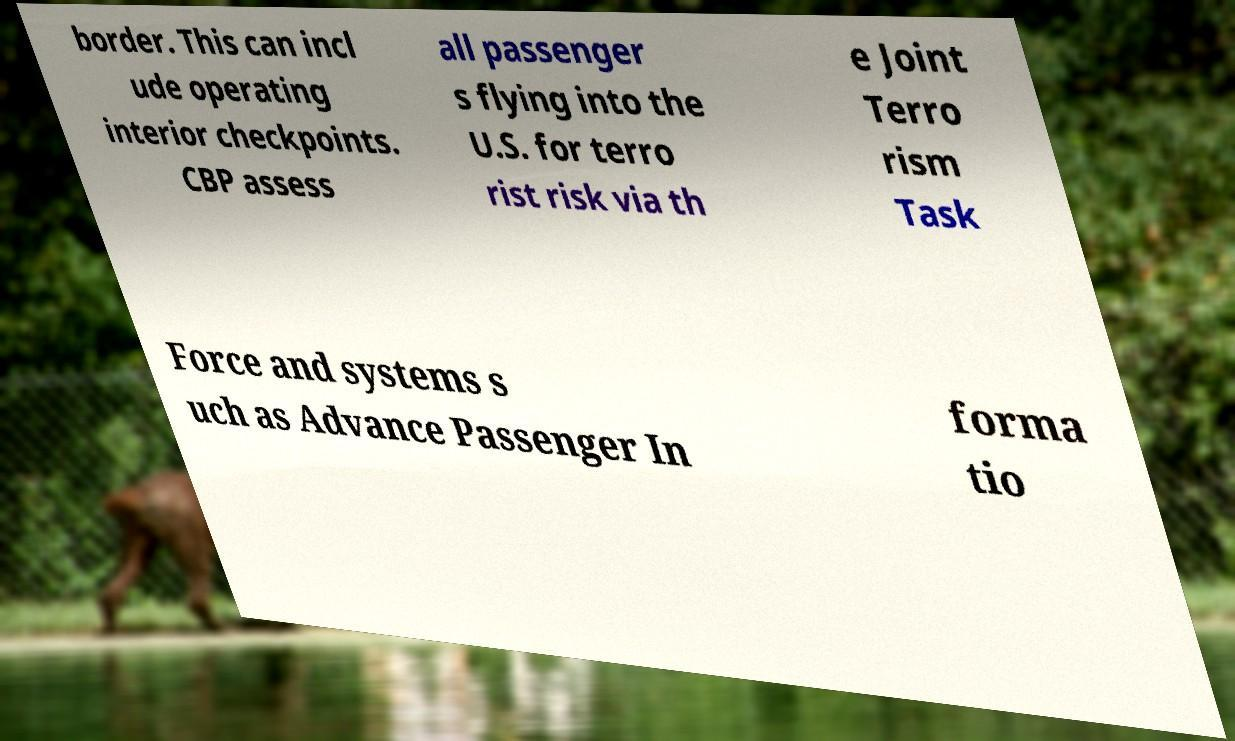There's text embedded in this image that I need extracted. Can you transcribe it verbatim? border. This can incl ude operating interior checkpoints. CBP assess all passenger s flying into the U.S. for terro rist risk via th e Joint Terro rism Task Force and systems s uch as Advance Passenger In forma tio 